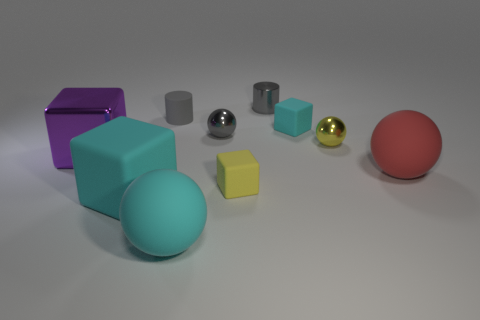There is a matte sphere behind the large matte ball that is to the left of the big red thing; what color is it?
Your answer should be very brief. Red. What is the shape of the red matte thing?
Give a very brief answer. Sphere. There is a gray thing that is both in front of the metal cylinder and to the right of the matte cylinder; what shape is it?
Offer a very short reply. Sphere. The tiny block that is the same material as the tiny cyan object is what color?
Provide a short and direct response. Yellow. The thing to the right of the yellow thing that is on the right side of the small cube that is behind the large purple thing is what shape?
Your response must be concise. Sphere. What is the size of the gray matte cylinder?
Provide a succinct answer. Small. What is the shape of the yellow object that is the same material as the purple block?
Your response must be concise. Sphere. Is the number of big red balls behind the yellow matte cube less than the number of large blue matte objects?
Your answer should be very brief. No. There is a small metal thing that is behind the gray rubber object; what is its color?
Your response must be concise. Gray. There is a small ball that is the same color as the tiny shiny cylinder; what material is it?
Keep it short and to the point. Metal. 